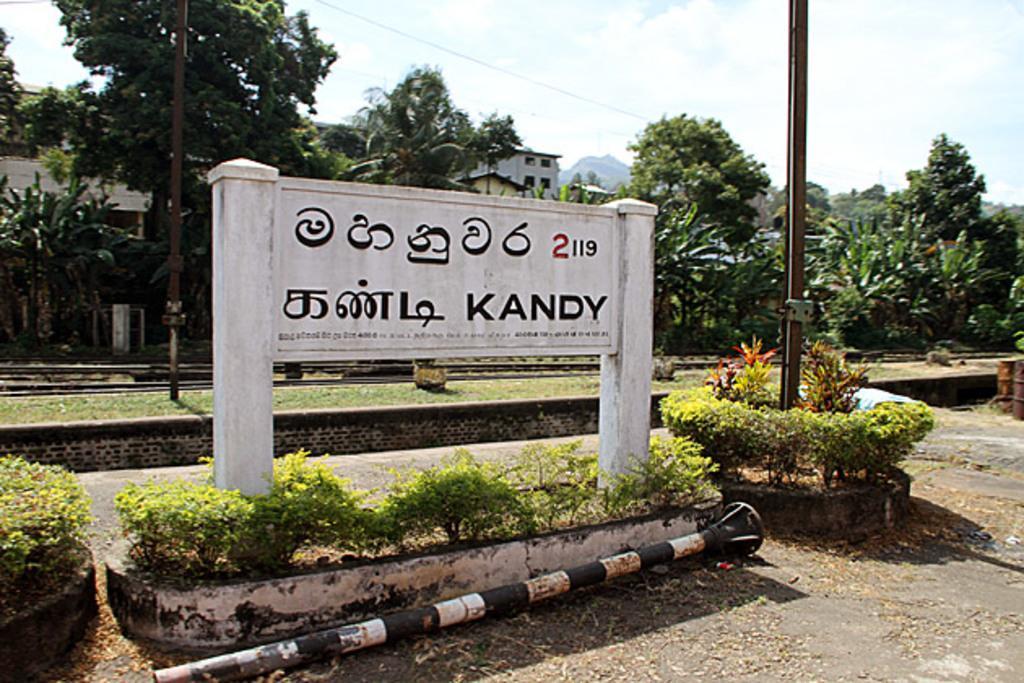In one or two sentences, can you explain what this image depicts? These are trees and houses, this is pole and a sky. 